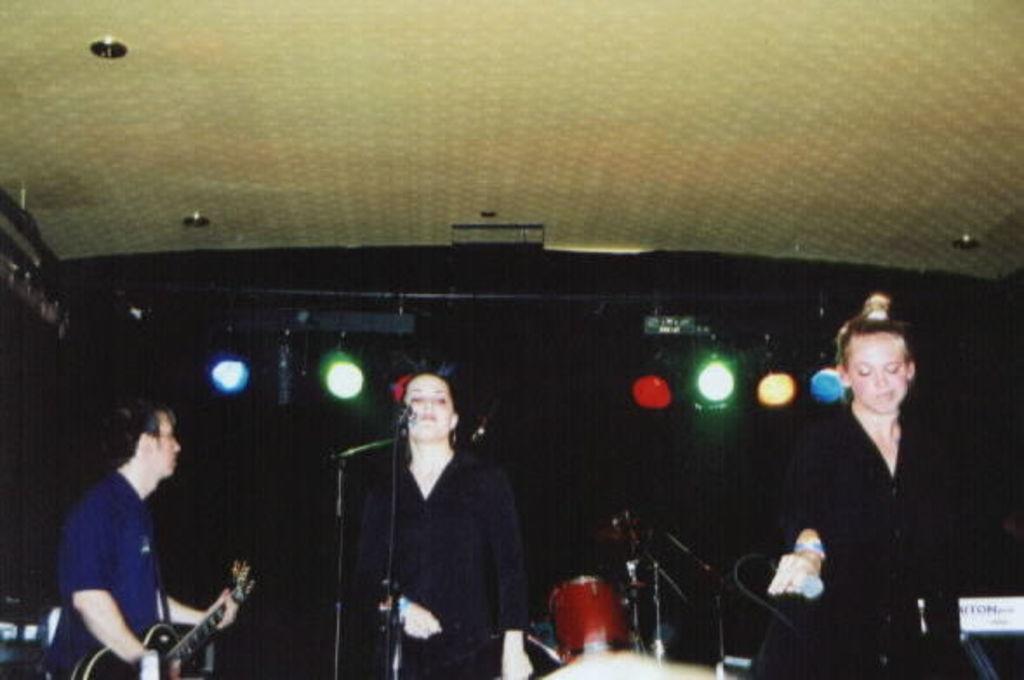Can you describe this image briefly? In the middle of the image a woman is standing in front of the microphone. Bottom right side of the image a woman is standing and holding a microphone. In the middle of the image there is a drum. Bottom left side of the image a man is holding a guitar. At the top of the image there is a roof. 